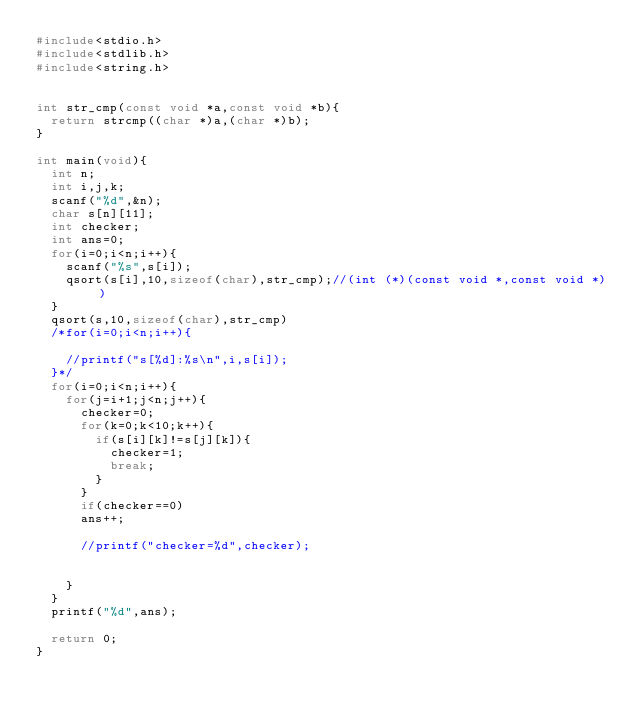<code> <loc_0><loc_0><loc_500><loc_500><_C_>#include<stdio.h>
#include<stdlib.h>
#include<string.h>


int str_cmp(const void *a,const void *b){
  return strcmp((char *)a,(char *)b);
}

int main(void){
  int n;
  int i,j,k;
  scanf("%d",&n);
  char s[n][11];
  int checker;
  int ans=0;
  for(i=0;i<n;i++){
    scanf("%s",s[i]);
    qsort(s[i],10,sizeof(char),str_cmp);//(int (*)(const void *,const void *))
  }
  qsort(s,10,sizeof(char),str_cmp)
  /*for(i=0;i<n;i++){

    //printf("s[%d]:%s\n",i,s[i]);
  }*/
  for(i=0;i<n;i++){
    for(j=i+1;j<n;j++){
      checker=0;
      for(k=0;k<10;k++){
        if(s[i][k]!=s[j][k]){
          checker=1;
          break;
        }
      }
      if(checker==0)
      ans++;

      //printf("checker=%d",checker);


    }
  }
  printf("%d",ans);

  return 0;
}
</code> 